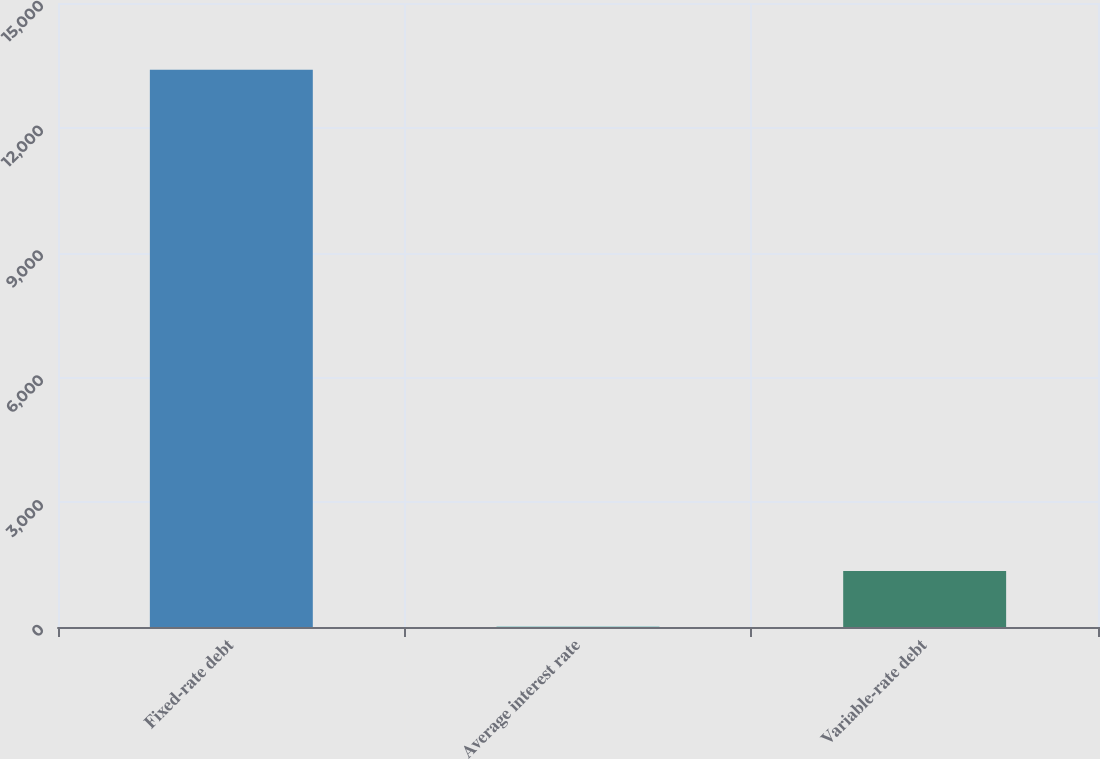Convert chart to OTSL. <chart><loc_0><loc_0><loc_500><loc_500><bar_chart><fcel>Fixed-rate debt<fcel>Average interest rate<fcel>Variable-rate debt<nl><fcel>13397<fcel>5.4<fcel>1344.56<nl></chart> 